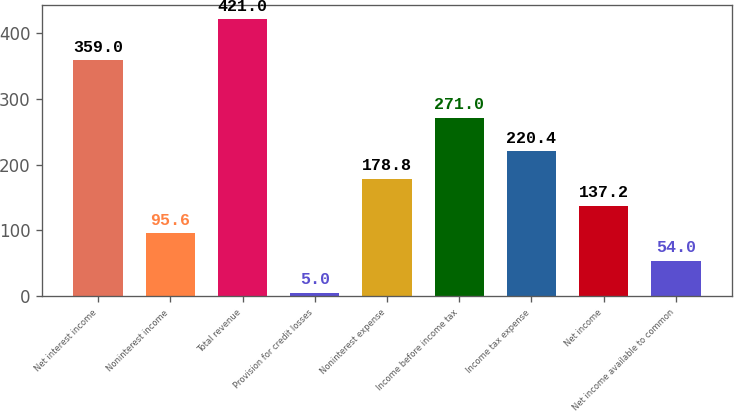Convert chart to OTSL. <chart><loc_0><loc_0><loc_500><loc_500><bar_chart><fcel>Net interest income<fcel>Noninterest income<fcel>Total revenue<fcel>Provision for credit losses<fcel>Noninterest expense<fcel>Income before income tax<fcel>Income tax expense<fcel>Net income<fcel>Net income available to common<nl><fcel>359<fcel>95.6<fcel>421<fcel>5<fcel>178.8<fcel>271<fcel>220.4<fcel>137.2<fcel>54<nl></chart> 